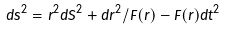<formula> <loc_0><loc_0><loc_500><loc_500>d s ^ { 2 } = r ^ { 2 } d S ^ { 2 } + d r ^ { 2 } / F ( r ) - F ( r ) d t ^ { 2 }</formula> 